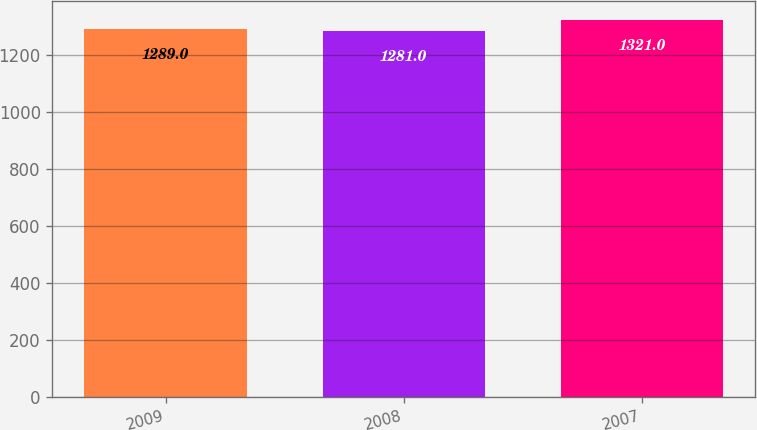Convert chart. <chart><loc_0><loc_0><loc_500><loc_500><bar_chart><fcel>2009<fcel>2008<fcel>2007<nl><fcel>1289<fcel>1281<fcel>1321<nl></chart> 